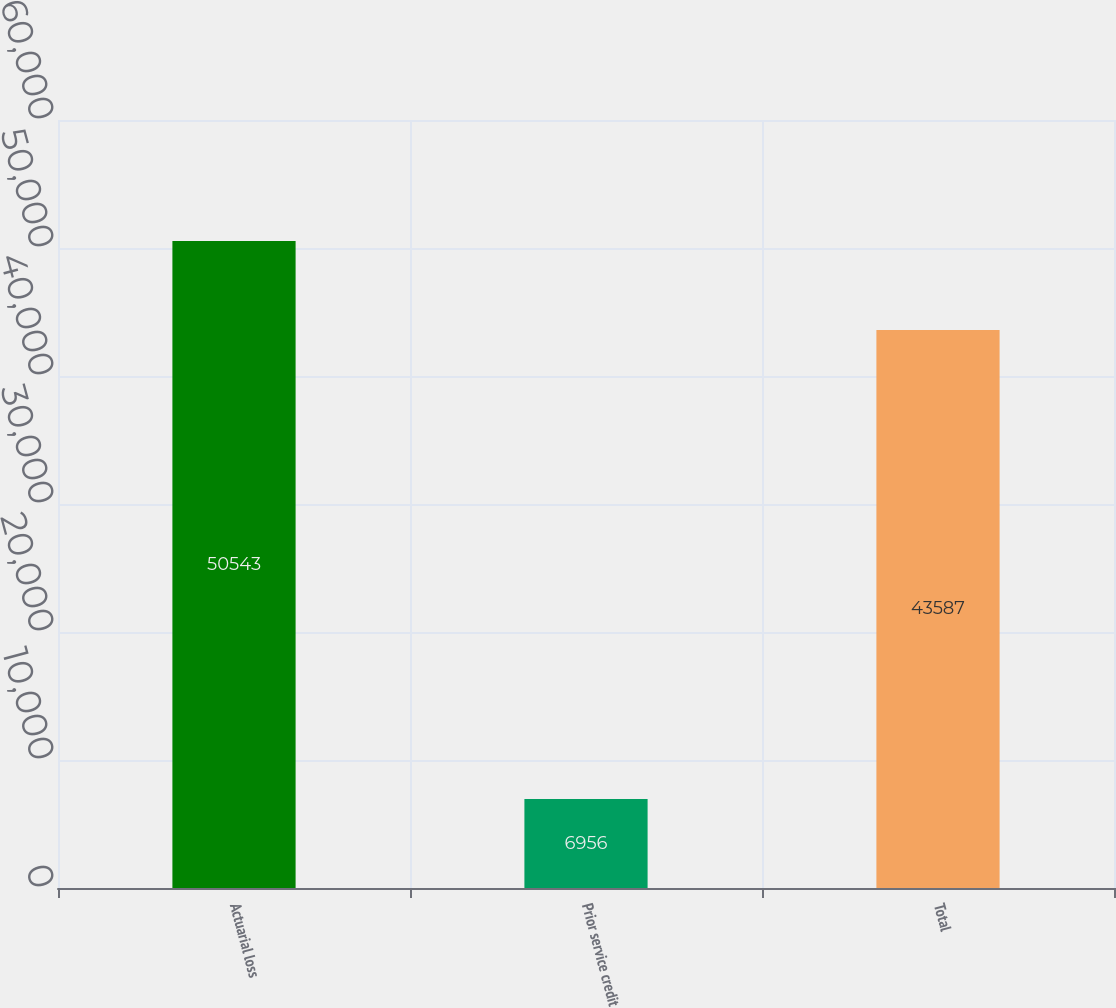Convert chart to OTSL. <chart><loc_0><loc_0><loc_500><loc_500><bar_chart><fcel>Actuarial loss<fcel>Prior service credit<fcel>Total<nl><fcel>50543<fcel>6956<fcel>43587<nl></chart> 